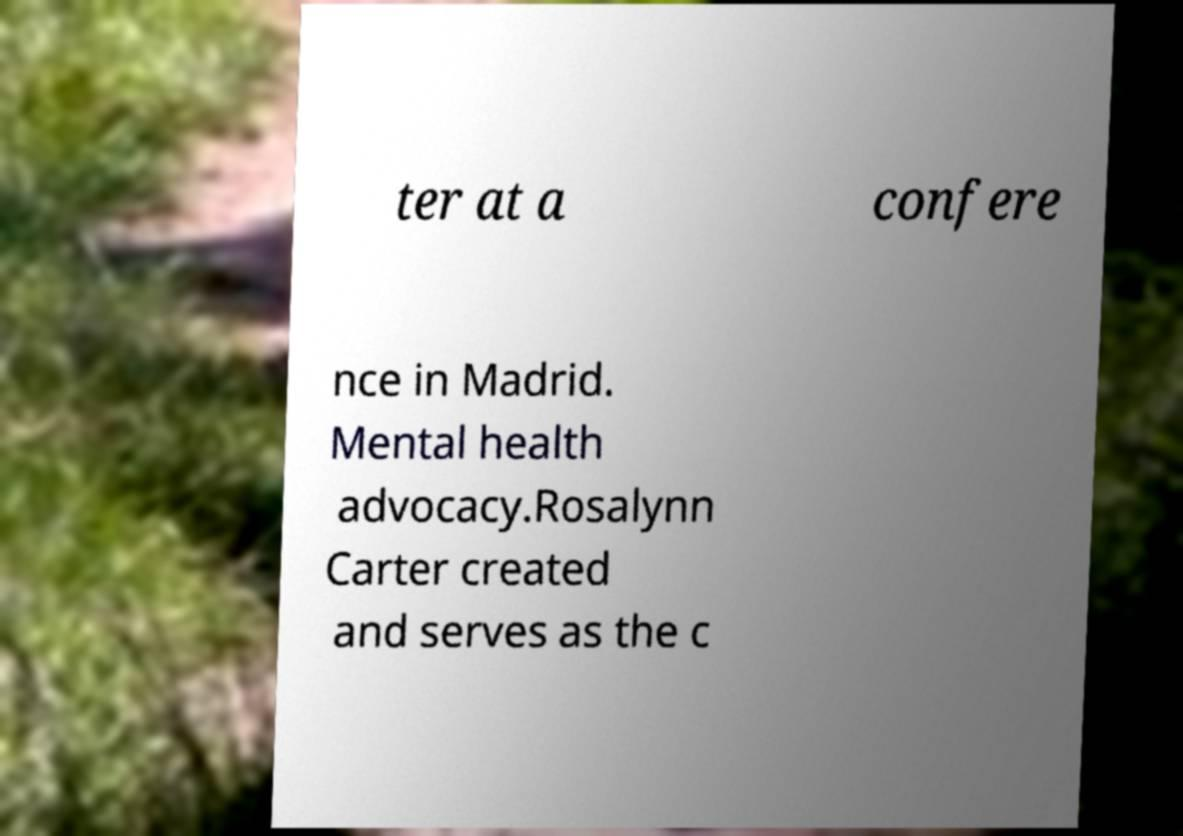Could you assist in decoding the text presented in this image and type it out clearly? ter at a confere nce in Madrid. Mental health advocacy.Rosalynn Carter created and serves as the c 